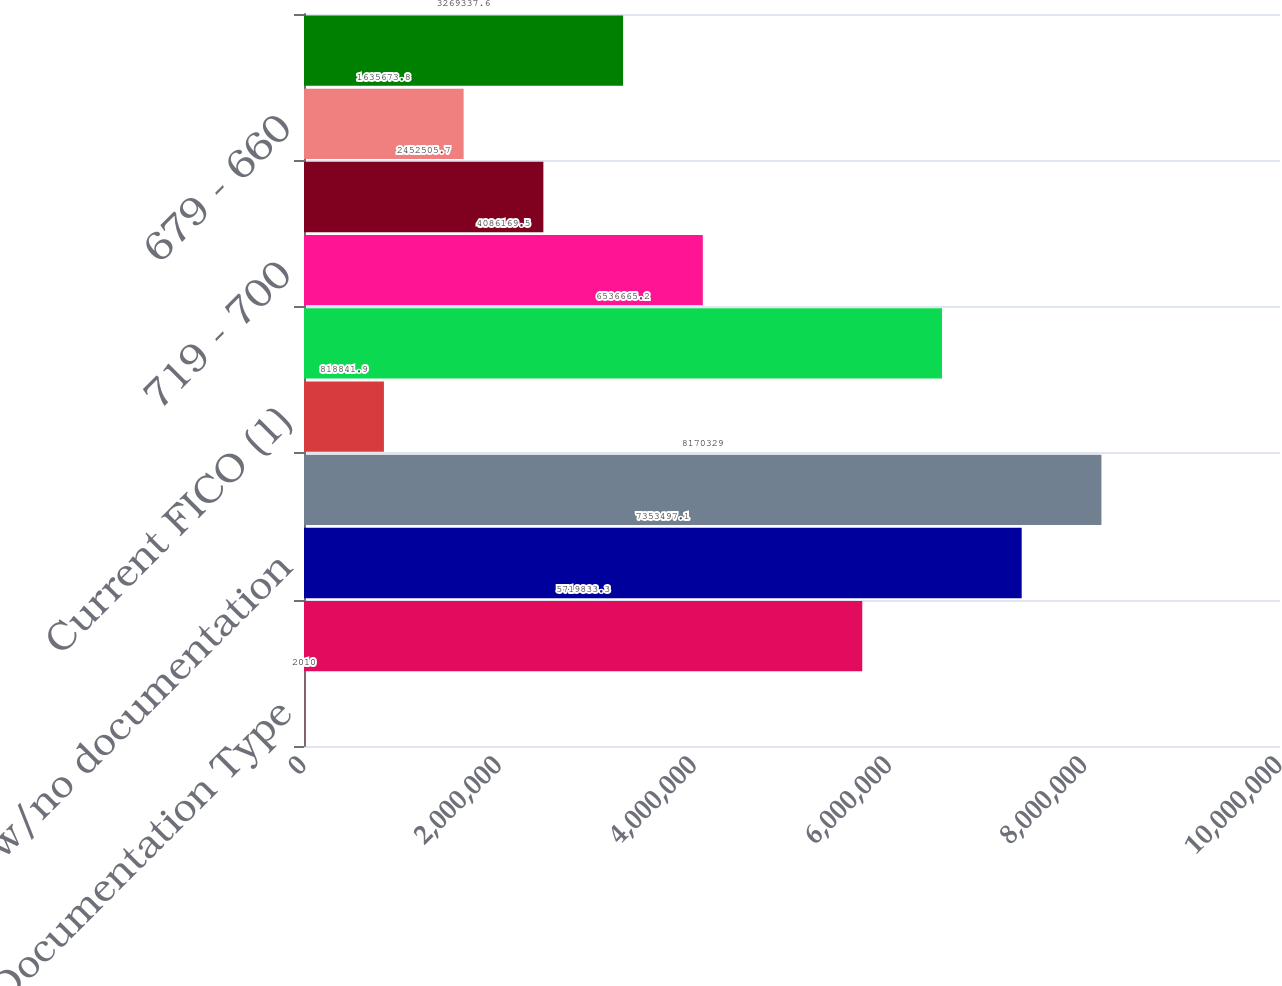<chart> <loc_0><loc_0><loc_500><loc_500><bar_chart><fcel>Documentation Type<fcel>Full documentation<fcel>Low/no documentation<fcel>Total mortgage loans<fcel>Current FICO (1)<fcel>=720<fcel>719 - 700<fcel>699 - 680<fcel>679 - 660<fcel>659 - 620<nl><fcel>2010<fcel>5.71983e+06<fcel>7.3535e+06<fcel>8.17033e+06<fcel>818842<fcel>6.53667e+06<fcel>4.08617e+06<fcel>2.45251e+06<fcel>1.63567e+06<fcel>3.26934e+06<nl></chart> 